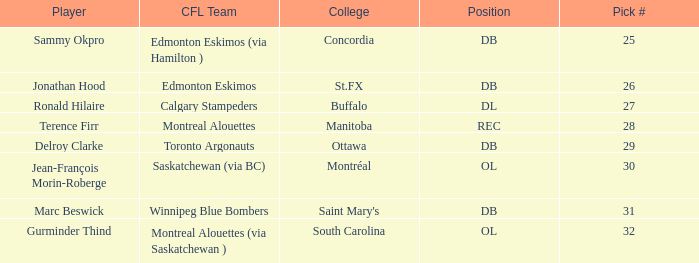At what pick number can concordia college be found? 25.0. 